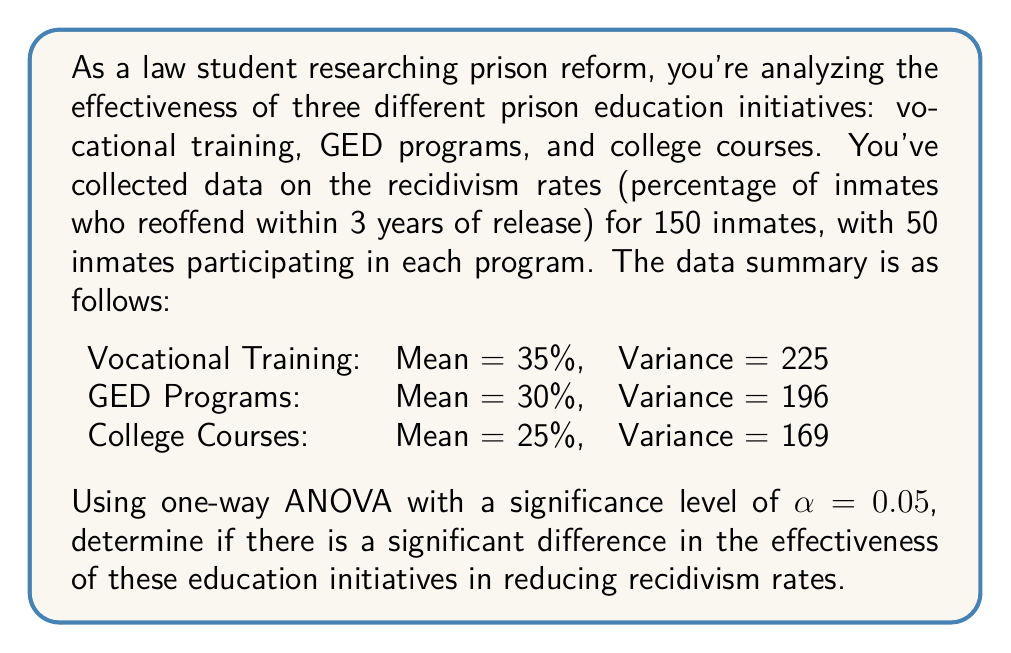Could you help me with this problem? To solve this problem using one-way ANOVA, we'll follow these steps:

1. State the null and alternative hypotheses:
   $H_0: \mu_1 = \mu_2 = \mu_3$ (all means are equal)
   $H_a:$ At least one mean is different

2. Calculate the total sum of squares (SST):
   $$SST = (n_1 - 1)s_1^2 + (n_2 - 1)s_2^2 + (n_3 - 1)s_3^2$$
   $$SST = 49 \cdot 225 + 49 \cdot 196 + 49 \cdot 169 = 28,910$$

3. Calculate the between-group sum of squares (SSB):
   $$SSB = n_1(\bar{x}_1 - \bar{x})^2 + n_2(\bar{x}_2 - \bar{x})^2 + n_3(\bar{x}_3 - \bar{x})^2$$
   where $\bar{x} = \frac{35 + 30 + 25}{3} = 30$
   $$SSB = 50(35 - 30)^2 + 50(30 - 30)^2 + 50(25 - 30)^2 = 1,250$$

4. Calculate the within-group sum of squares (SSW):
   $$SSW = SST - SSB = 28,910 - 1,250 = 27,660$$

5. Calculate degrees of freedom:
   $df_{between} = k - 1 = 3 - 1 = 2$
   $df_{within} = N - k = 150 - 3 = 147$
   $df_{total} = N - 1 = 150 - 1 = 149$

6. Calculate mean squares:
   $$MS_{between} = \frac{SSB}{df_{between}} = \frac{1,250}{2} = 625$$
   $$MS_{within} = \frac{SSW}{df_{within}} = \frac{27,660}{147} = 188.16$$

7. Calculate the F-statistic:
   $$F = \frac{MS_{between}}{MS_{within}} = \frac{625}{188.16} = 3.32$$

8. Find the critical F-value:
   $F_{crit} = F_{0.05,2,147} = 3.06$ (from F-distribution table)

9. Make a decision:
   Since $F = 3.32 > F_{crit} = 3.06$, we reject the null hypothesis.

10. Calculate p-value:
    Using an F-distribution calculator, we find $p = 0.0389$.
Answer: Reject the null hypothesis. There is a significant difference in the effectiveness of the three prison education initiatives in reducing recidivism rates (F(2, 147) = 3.32, p = 0.0389 < 0.05). 